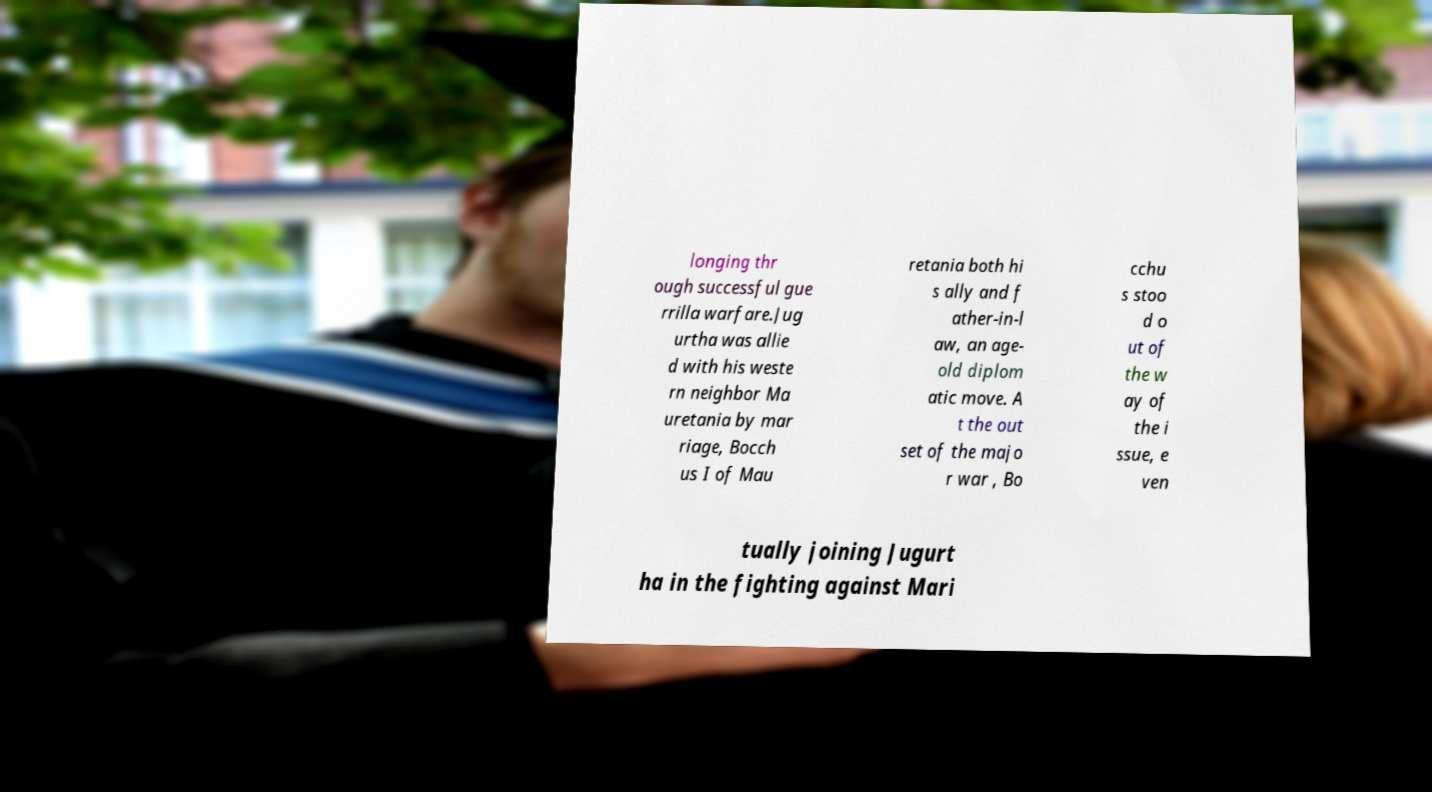For documentation purposes, I need the text within this image transcribed. Could you provide that? longing thr ough successful gue rrilla warfare.Jug urtha was allie d with his weste rn neighbor Ma uretania by mar riage, Bocch us I of Mau retania both hi s ally and f ather-in-l aw, an age- old diplom atic move. A t the out set of the majo r war , Bo cchu s stoo d o ut of the w ay of the i ssue, e ven tually joining Jugurt ha in the fighting against Mari 